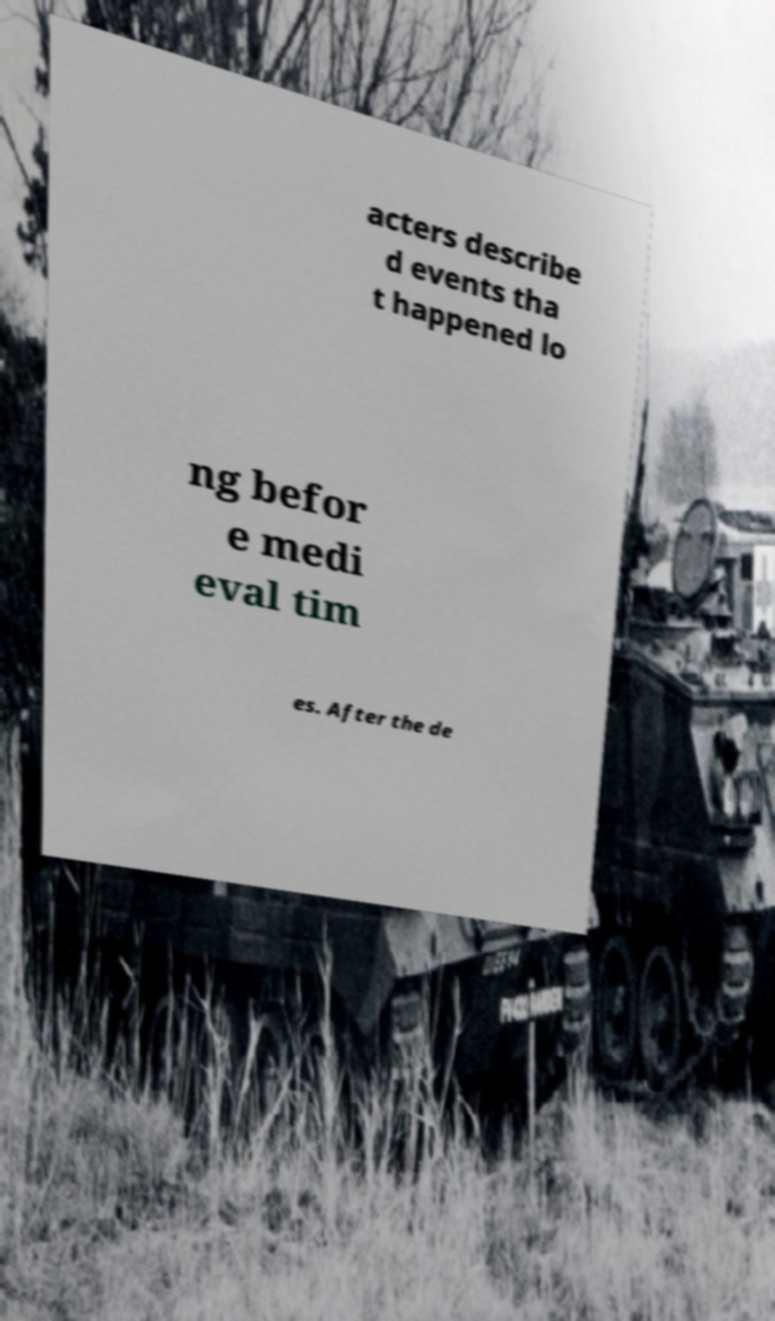Please identify and transcribe the text found in this image. acters describe d events tha t happened lo ng befor e medi eval tim es. After the de 